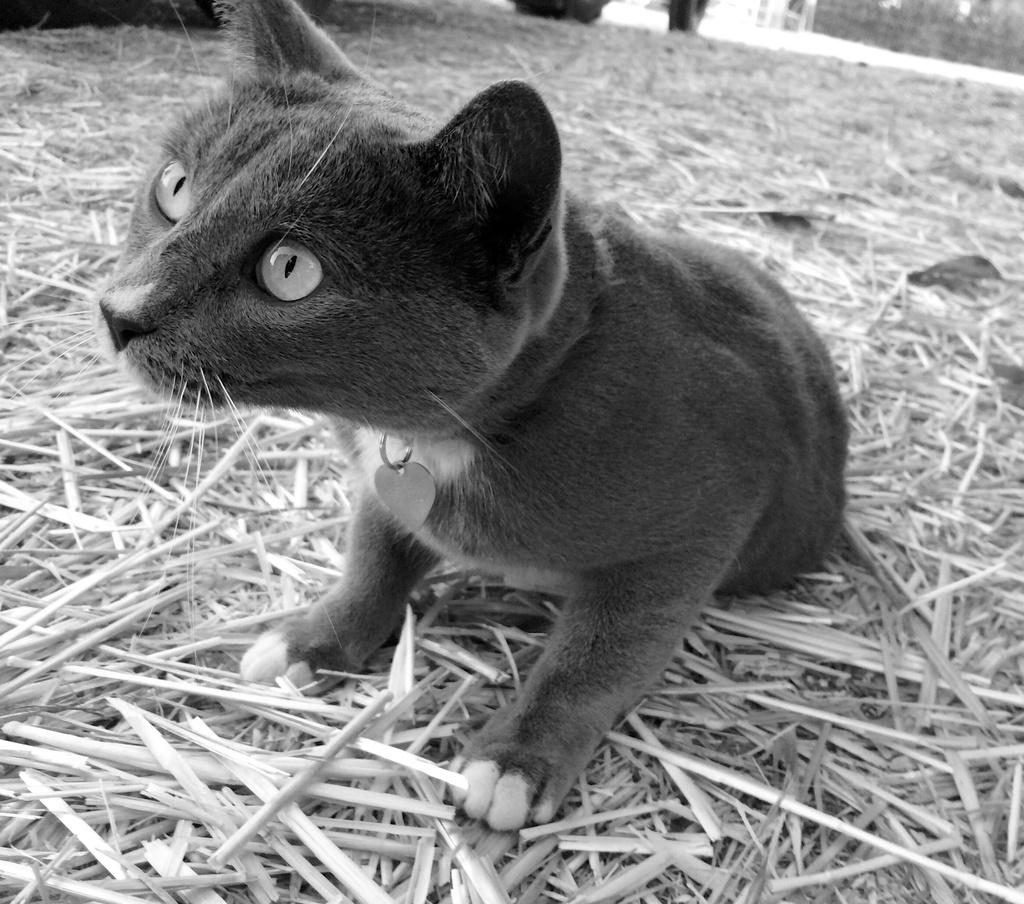What type of living creature can be seen in the image? There is an animal in the image. What other elements are present in the image besides the animal? There are many plants and dry grass in the image. What type of oatmeal is being prepared in the image? There is no oatmeal present in the image. What activity is the animal engaged in within the image? The provided facts do not mention any specific activity the animal is engaged in. 